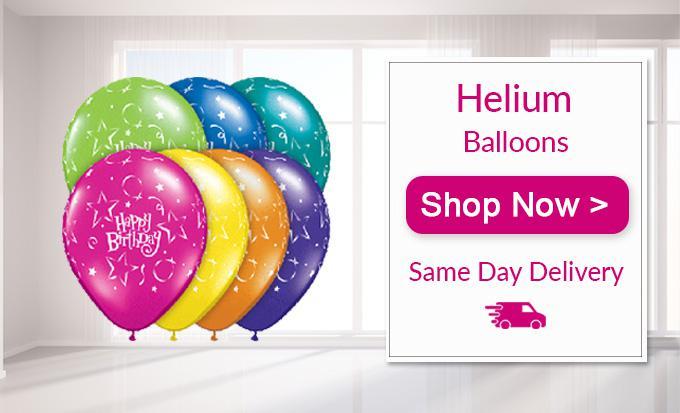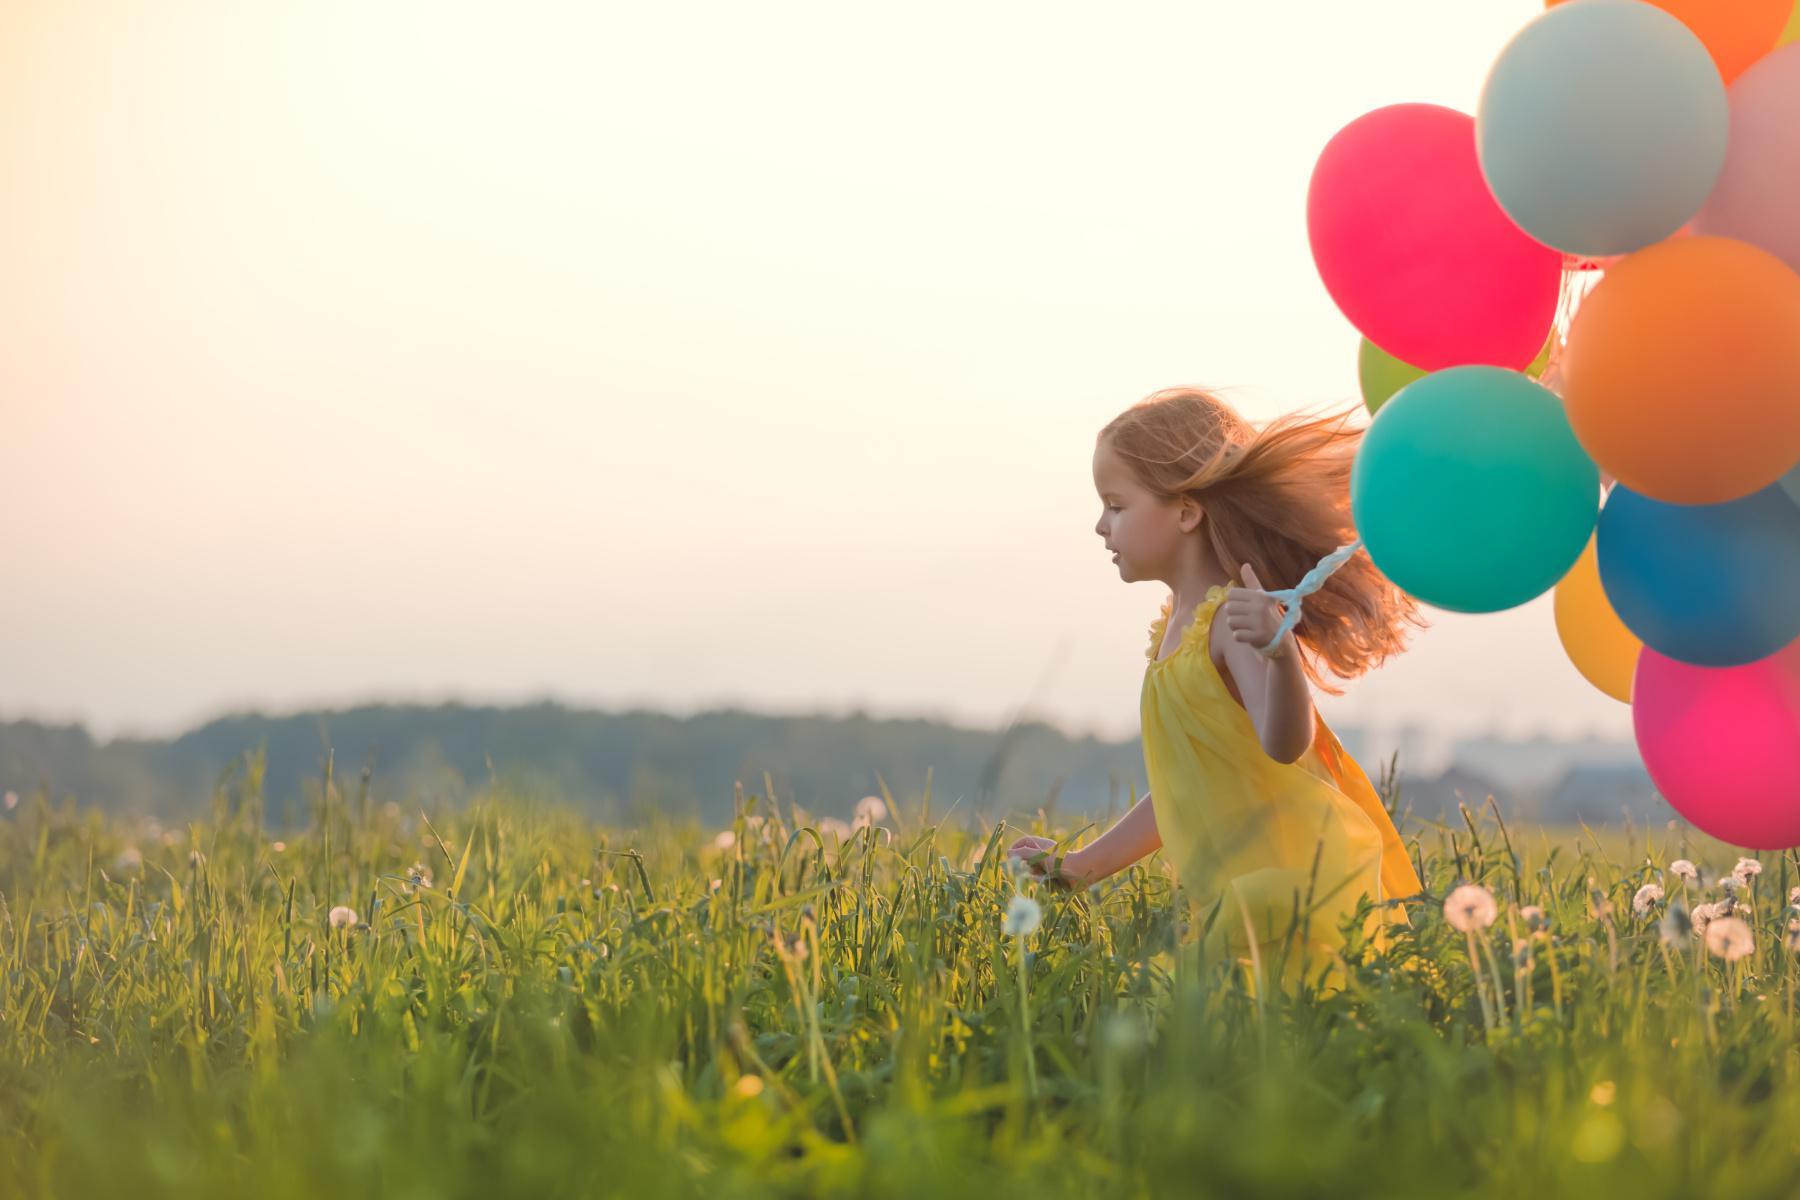The first image is the image on the left, the second image is the image on the right. Assess this claim about the two images: "There is a single balloon in the left image.". Correct or not? Answer yes or no. No. The first image is the image on the left, the second image is the image on the right. For the images displayed, is the sentence "There are no more than seven balloons with at least one looking like a piece of wrapped candy." factually correct? Answer yes or no. No. 